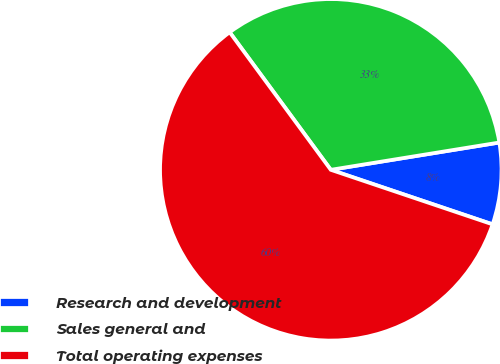Convert chart. <chart><loc_0><loc_0><loc_500><loc_500><pie_chart><fcel>Research and development<fcel>Sales general and<fcel>Total operating expenses<nl><fcel>7.73%<fcel>32.53%<fcel>59.73%<nl></chart> 